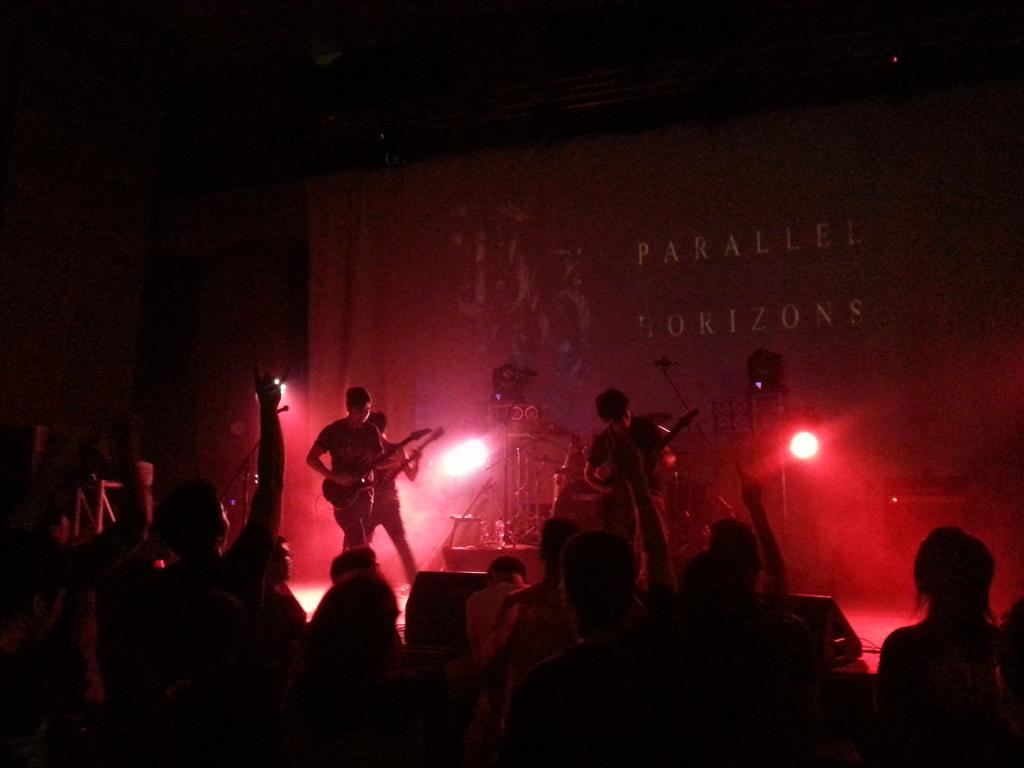How many people are in the image? There are persons in the image. Can you describe the setting of the image? Three persons are in front of a banner, and they are playing guitars. What else can be seen in the image? There are lights and musical instruments in the middle of the image. What type of plane is visible in the image? There is no plane present in the image. What color is the silver bucket in the image? There is no silver bucket present in the image. 